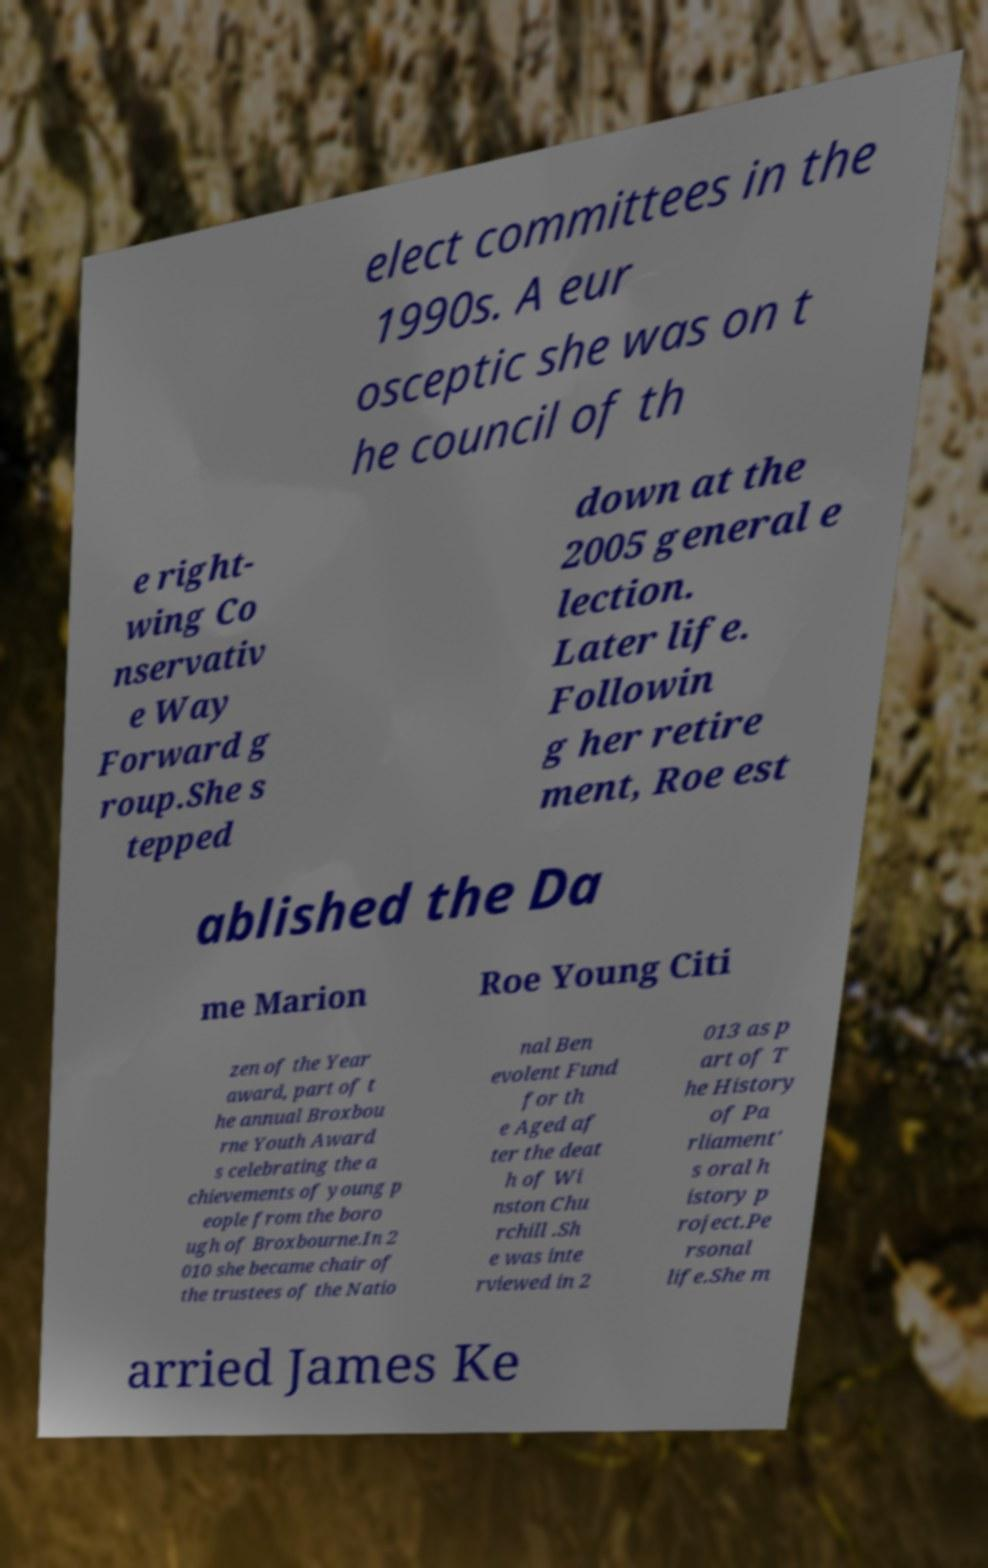Could you assist in decoding the text presented in this image and type it out clearly? elect committees in the 1990s. A eur osceptic she was on t he council of th e right- wing Co nservativ e Way Forward g roup.She s tepped down at the 2005 general e lection. Later life. Followin g her retire ment, Roe est ablished the Da me Marion Roe Young Citi zen of the Year award, part of t he annual Broxbou rne Youth Award s celebrating the a chievements of young p eople from the boro ugh of Broxbourne.In 2 010 she became chair of the trustees of the Natio nal Ben evolent Fund for th e Aged af ter the deat h of Wi nston Chu rchill .Sh e was inte rviewed in 2 013 as p art of T he History of Pa rliament' s oral h istory p roject.Pe rsonal life.She m arried James Ke 